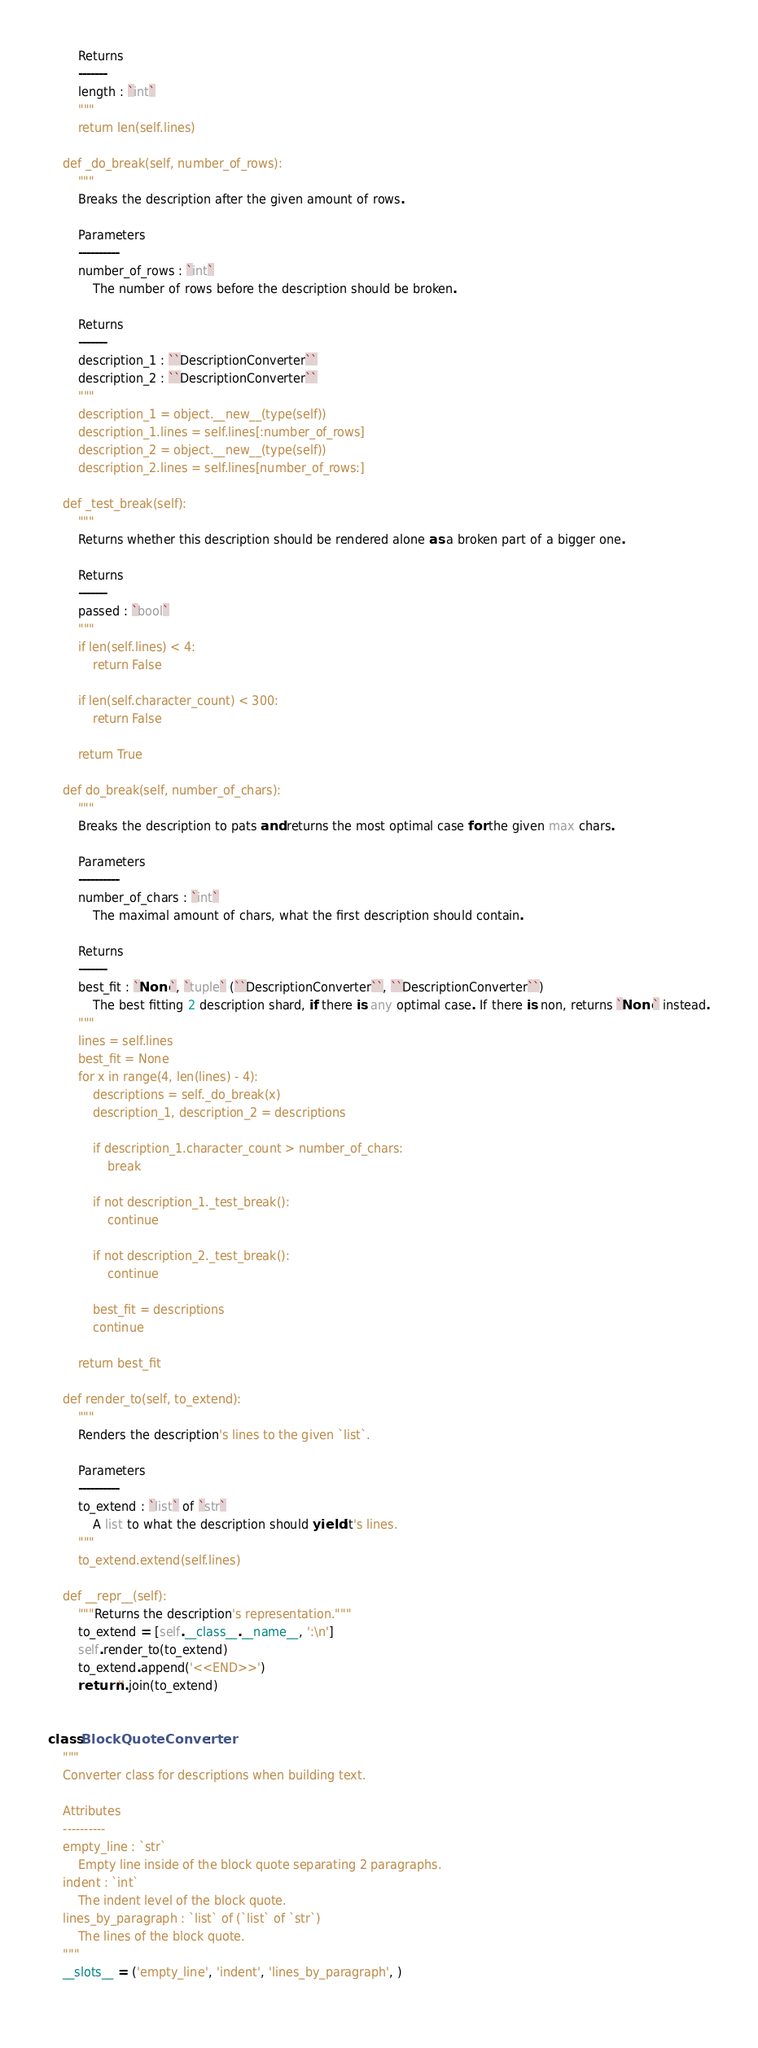<code> <loc_0><loc_0><loc_500><loc_500><_Python_>        Returns
        -------
        length : `int`
        """
        return len(self.lines)
    
    def _do_break(self, number_of_rows):
        """
        Breaks the description after the given amount of rows.
        
        Parameters
        ----------
        number_of_rows : `int`
            The number of rows before the description should be broken.
        
        Returns
        -------
        description_1 : ``DescriptionConverter``
        description_2 : ``DescriptionConverter``
        """
        description_1 = object.__new__(type(self))
        description_1.lines = self.lines[:number_of_rows]
        description_2 = object.__new__(type(self))
        description_2.lines = self.lines[number_of_rows:]
    
    def _test_break(self):
        """
        Returns whether this description should be rendered alone as a broken part of a bigger one.
        
        Returns
        -------
        passed : `bool`
        """
        if len(self.lines) < 4:
            return False
        
        if len(self.character_count) < 300:
            return False
        
        return True
    
    def do_break(self, number_of_chars):
        """
        Breaks the description to pats and returns the most optimal case for the given max chars.
        
        Parameters
        ----------
        number_of_chars : `int`
            The maximal amount of chars, what the first description should contain.

        Returns
        -------
        best_fit : `None`, `tuple` (``DescriptionConverter``, ``DescriptionConverter``)
            The best fitting 2 description shard, if there is any optimal case. If there is non, returns `None` instead.
        """
        lines = self.lines
        best_fit = None
        for x in range(4, len(lines) - 4):
            descriptions = self._do_break(x)
            description_1, description_2 = descriptions
            
            if description_1.character_count > number_of_chars:
                break
            
            if not description_1._test_break():
                continue
            
            if not description_2._test_break():
                continue
            
            best_fit = descriptions
            continue
        
        return best_fit
    
    def render_to(self, to_extend):
        """
        Renders the description's lines to the given `list`.
        
        Parameters
        ----------
        to_extend : `list` of `str`
            A list to what the description should yield it's lines.
        """
        to_extend.extend(self.lines)
    
    def __repr__(self):
        """Returns the description's representation."""
        to_extend = [self.__class__.__name__, ':\n']
        self.render_to(to_extend)
        to_extend.append('<<END>>')
        return ''.join(to_extend)


class BlockQuoteConverter:
    """
    Converter class for descriptions when building text.
    
    Attributes
    ----------
    empty_line : `str`
        Empty line inside of the block quote separating 2 paragraphs.
    indent : `int`
        The indent level of the block quote.
    lines_by_paragraph : `list` of (`list` of `str`)
        The lines of the block quote.
    """
    __slots__ = ('empty_line', 'indent', 'lines_by_paragraph', )
    </code> 